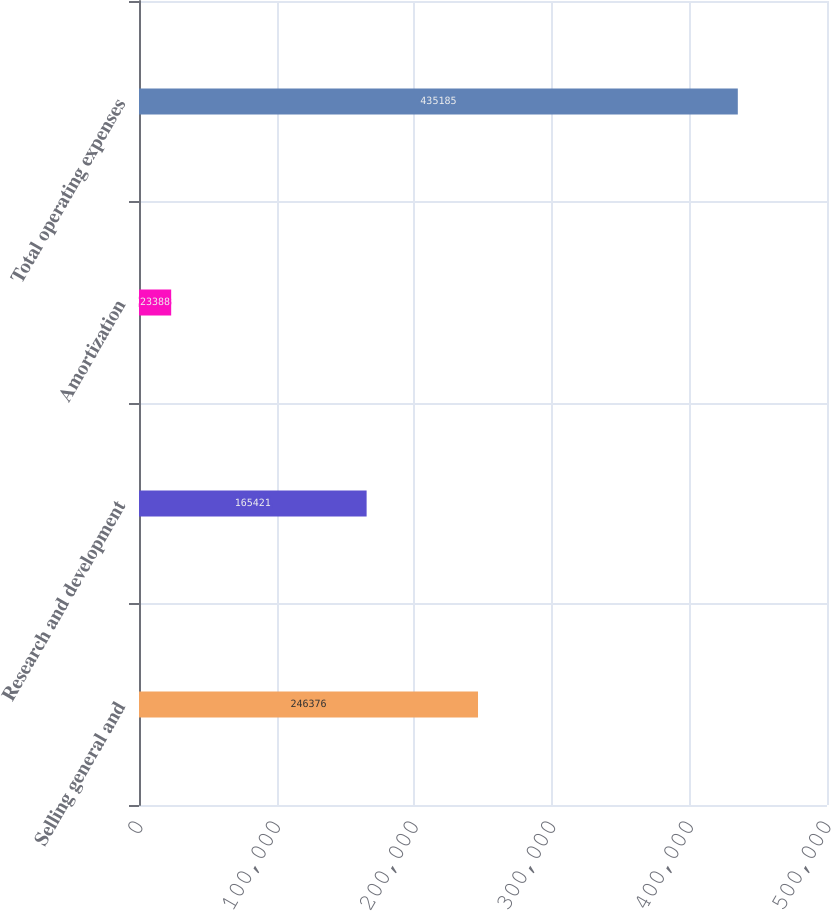Convert chart to OTSL. <chart><loc_0><loc_0><loc_500><loc_500><bar_chart><fcel>Selling general and<fcel>Research and development<fcel>Amortization<fcel>Total operating expenses<nl><fcel>246376<fcel>165421<fcel>23388<fcel>435185<nl></chart> 